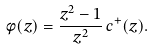<formula> <loc_0><loc_0><loc_500><loc_500>\phi ( z ) = \frac { z ^ { 2 } - 1 } { z ^ { 2 } } \, c ^ { + } ( z ) .</formula> 